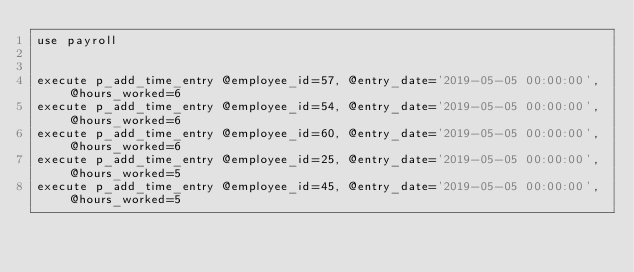<code> <loc_0><loc_0><loc_500><loc_500><_SQL_>use payroll


execute p_add_time_entry @employee_id=57, @entry_date='2019-05-05 00:00:00', @hours_worked=6
execute p_add_time_entry @employee_id=54, @entry_date='2019-05-05 00:00:00', @hours_worked=6
execute p_add_time_entry @employee_id=60, @entry_date='2019-05-05 00:00:00', @hours_worked=6
execute p_add_time_entry @employee_id=25, @entry_date='2019-05-05 00:00:00', @hours_worked=5
execute p_add_time_entry @employee_id=45, @entry_date='2019-05-05 00:00:00', @hours_worked=5

</code> 